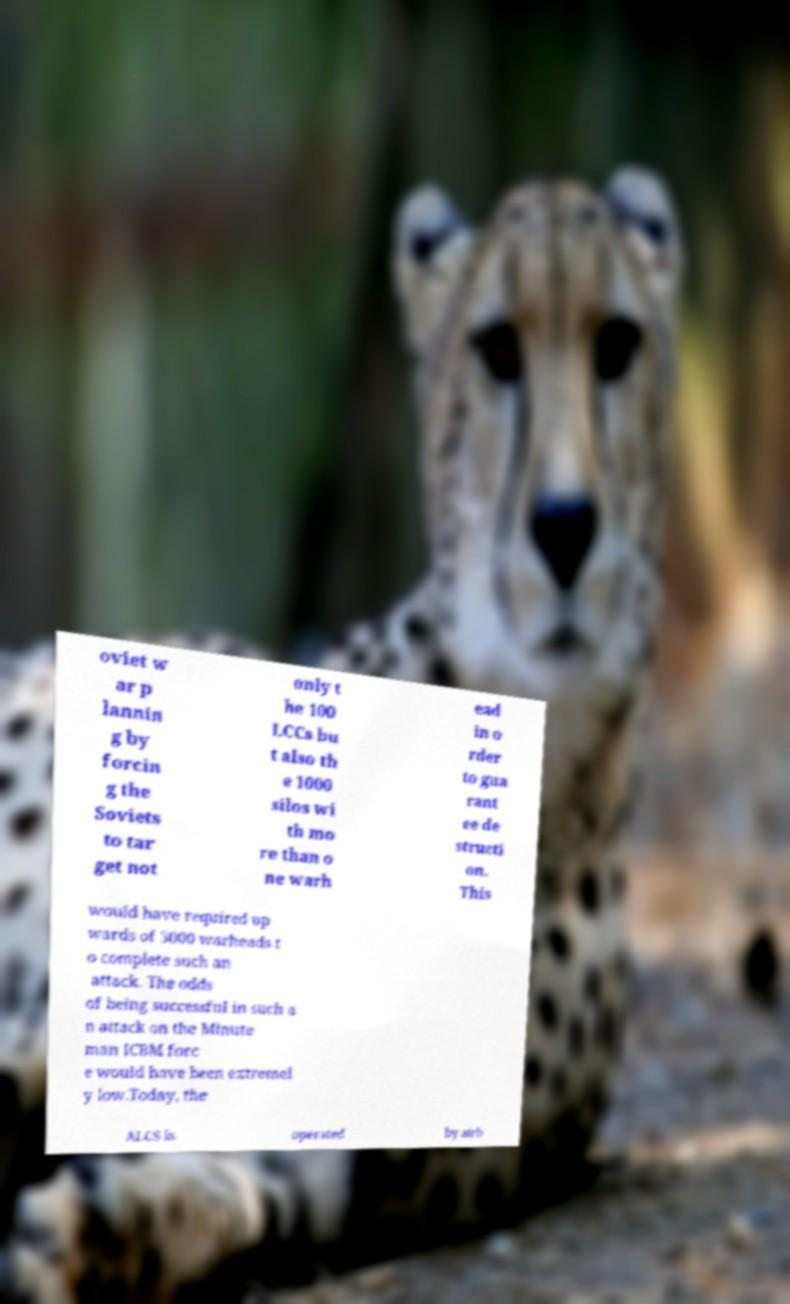Please read and relay the text visible in this image. What does it say? oviet w ar p lannin g by forcin g the Soviets to tar get not only t he 100 LCCs bu t also th e 1000 silos wi th mo re than o ne warh ead in o rder to gua rant ee de structi on. This would have required up wards of 3000 warheads t o complete such an attack. The odds of being successful in such a n attack on the Minute man ICBM forc e would have been extremel y low.Today, the ALCS is operated by airb 